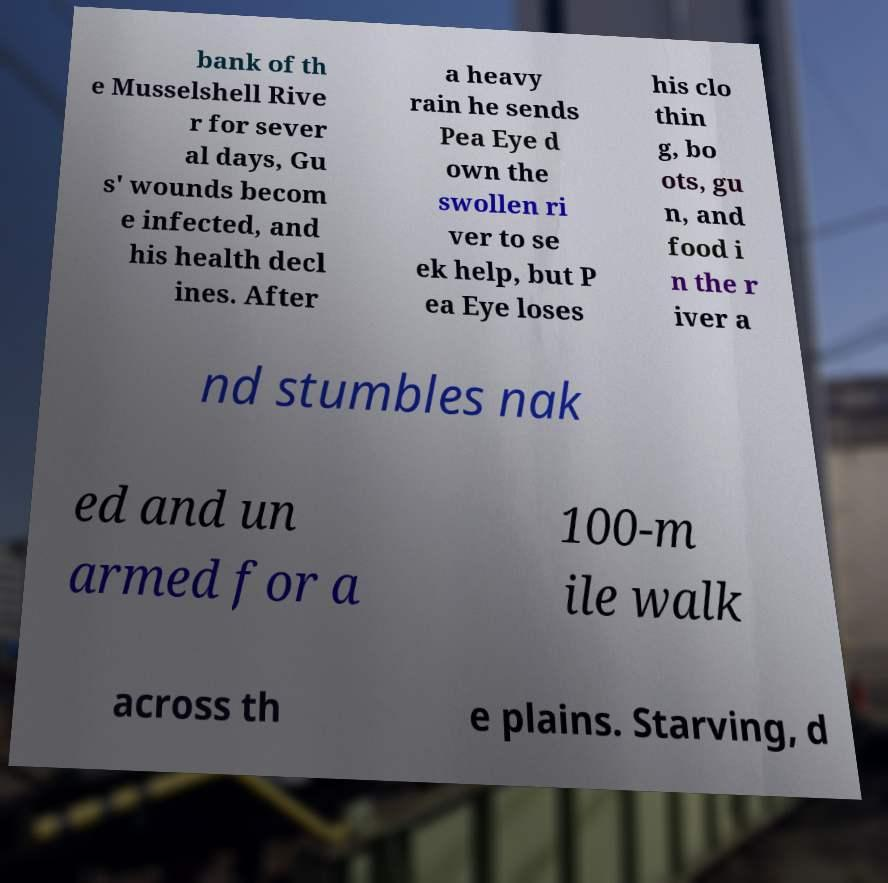Could you assist in decoding the text presented in this image and type it out clearly? bank of th e Musselshell Rive r for sever al days, Gu s' wounds becom e infected, and his health decl ines. After a heavy rain he sends Pea Eye d own the swollen ri ver to se ek help, but P ea Eye loses his clo thin g, bo ots, gu n, and food i n the r iver a nd stumbles nak ed and un armed for a 100-m ile walk across th e plains. Starving, d 